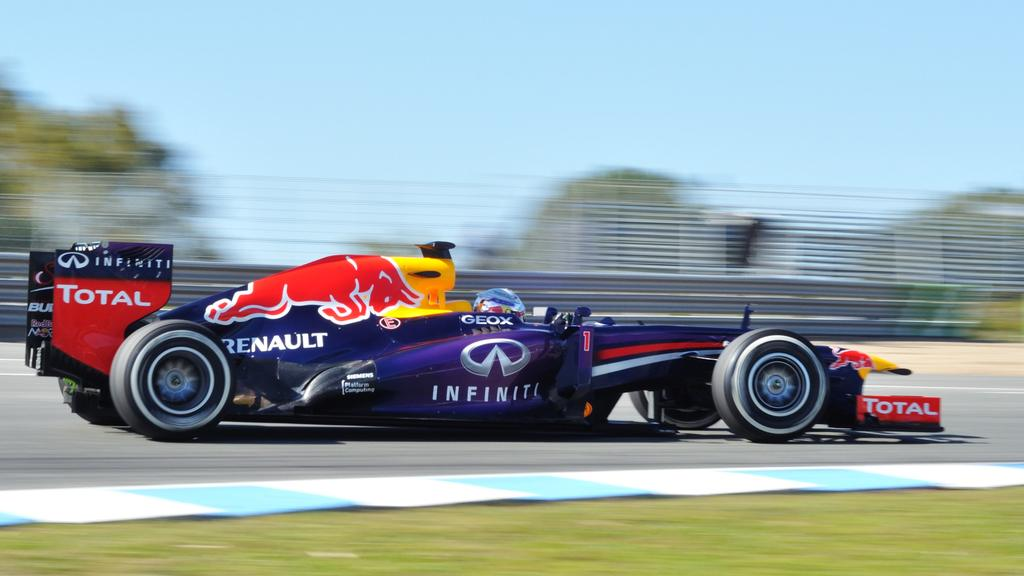What is the main subject of the image? The main subject of the image is a racing car. Where is the racing car located? The racing car is on the road. What can be seen in the background of the image? There are trees and the sky visible in the background of the image. What type of bean is being rubbed in the image? There is no bean or rubbing action present in the image. 